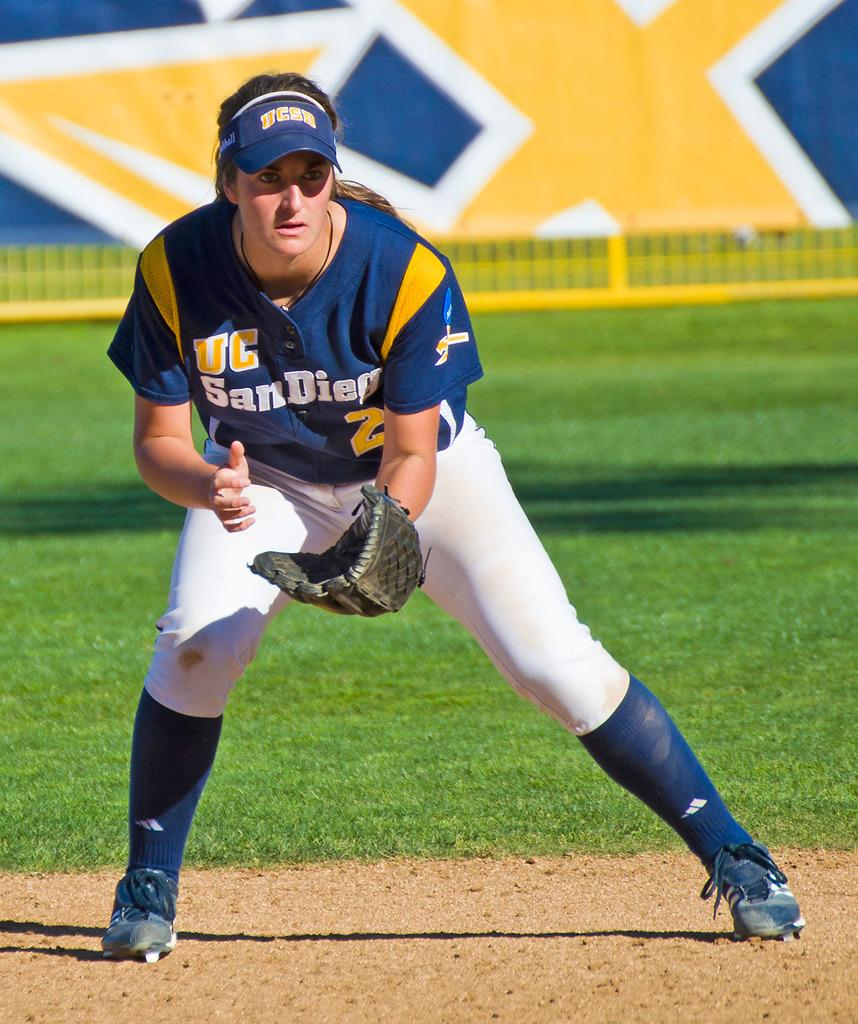<image>
Describe the image concisely. A person wearing a UC San Diego jersey and a catcher's mitt on a playing field. 